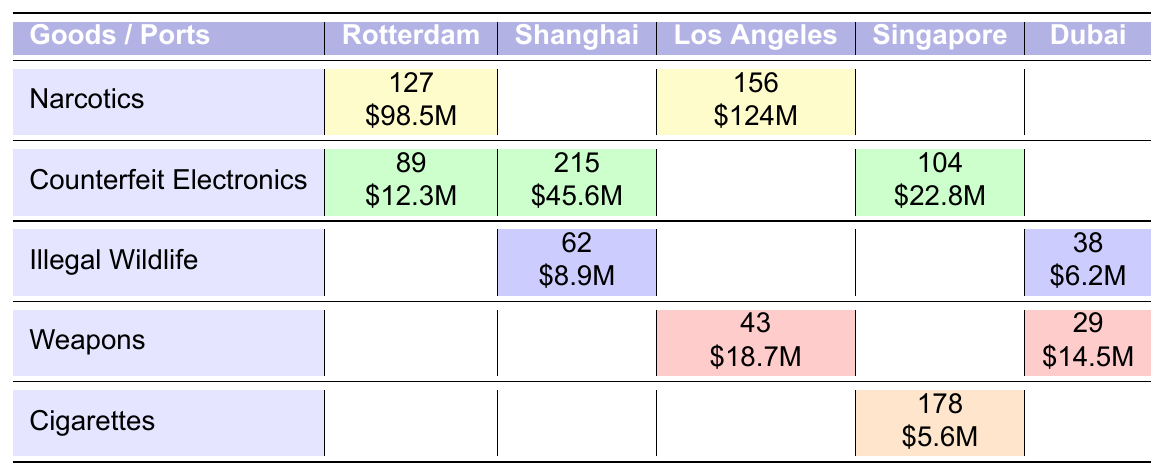What is the total number of seizures for Narcotics across all ports? The number of seizures for Narcotics is 127 in Rotterdam and 156 in Los Angeles. Adding these gives a total of 127 + 156 = 283.
Answer: 283 Which port has the highest estimated value for Counterfeit Electronics? In the table, Counterfeit Electronics has a value of $12.3M in Rotterdam, $45.6M in Shanghai, and $22.8M in Singapore. The highest value is $45.6M in Shanghai.
Answer: Shanghai How many seizures of Illegal Wildlife were recorded in total? The total seizures for Illegal Wildlife is the sum of 62 in Shanghai and 38 in Dubai, which equals 62 + 38 = 100.
Answer: 100 Is there a port with zero seizures for Weapons? By looking at the table, there are only entries for Weapons in Los Angeles (43) and Dubai (29). Thus, there are no seizures recorded for Weapons in Rotterdam, Shanghai, and Singapore, which confirms that those ports have zero seizures.
Answer: Yes What is the average estimated value of all seizures recorded for Cigarettes? There is one entry for Cigarettes, which has a value of $5.6M in Singapore. Since there is only one seizure value, the average is simply $5.6M.
Answer: $5.6M How do the total seizures for Counterfeit Electronics compare to those for Narcotics? The total for Counterfeit Electronics is 89 (Rotterdam) + 215 (Shanghai) + 104 (Singapore) = 408. The total for Narcotics is 283. Comparing these: 408 (Counterfeit Electronics) - 283 (Narcotics) = 125 more seizures for Counterfeit Electronics.
Answer: 125 more seizures Which good has the lowest total market value across all ports? The market values for the goods are: Narcotics ($98.5M + $124M = $222.5M), Counterfeit Electronics ($12.3M + $45.6M + $22.8M = $80.7M), Illegal Wildlife ($8.9M + $6.2M = $15.1M), Weapons ($18.7M + $14.5M = $33.2M), and Cigarettes ($5.6M). The lowest value is Cigarettes at $5.6M.
Answer: Cigarettes What is the total number of seizures across all goods in Rotterdam? In Rotterdam, the total seizures are 127 (Narcotics) + 89 (Counterfeit Electronics) = 216.
Answer: 216 How much more value in estimated market value do the Narcotics have than the total value of Weapons seized? The total value for Narcotics is $98.5M + $124M = $222.5M. The total for Weapons is $18.7M + $14.5M = $33.2M. The difference in values is $222.5M - $33.2M = $189.3M.
Answer: $189.3M 